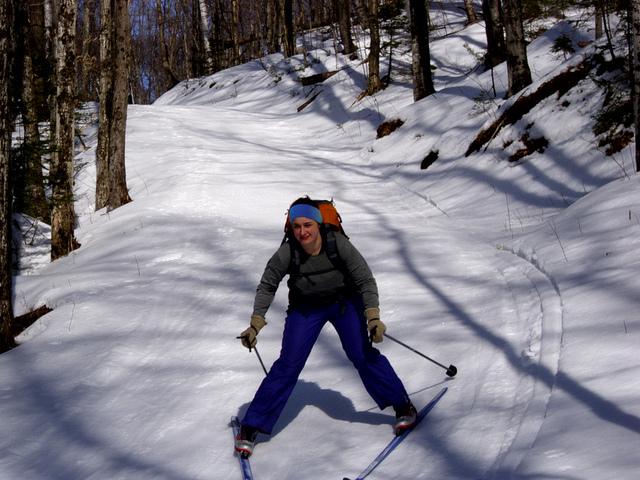Is the person going uphill or downhill?
Give a very brief answer. Downhill. What is the skier holding in hands?
Keep it brief. Poles. Are the woman's ears covered?
Be succinct. Yes. 